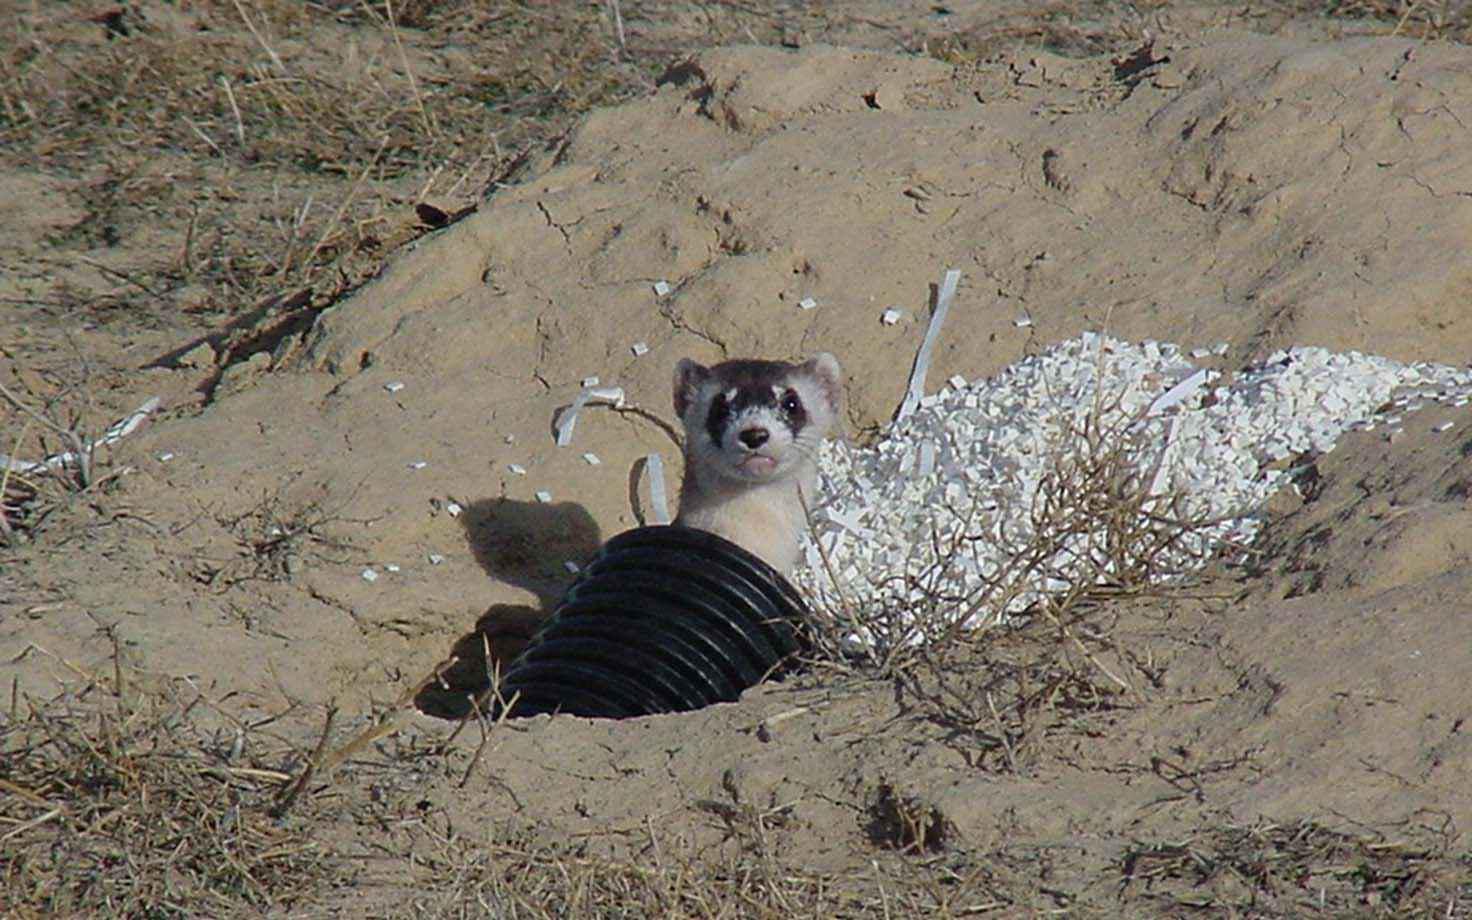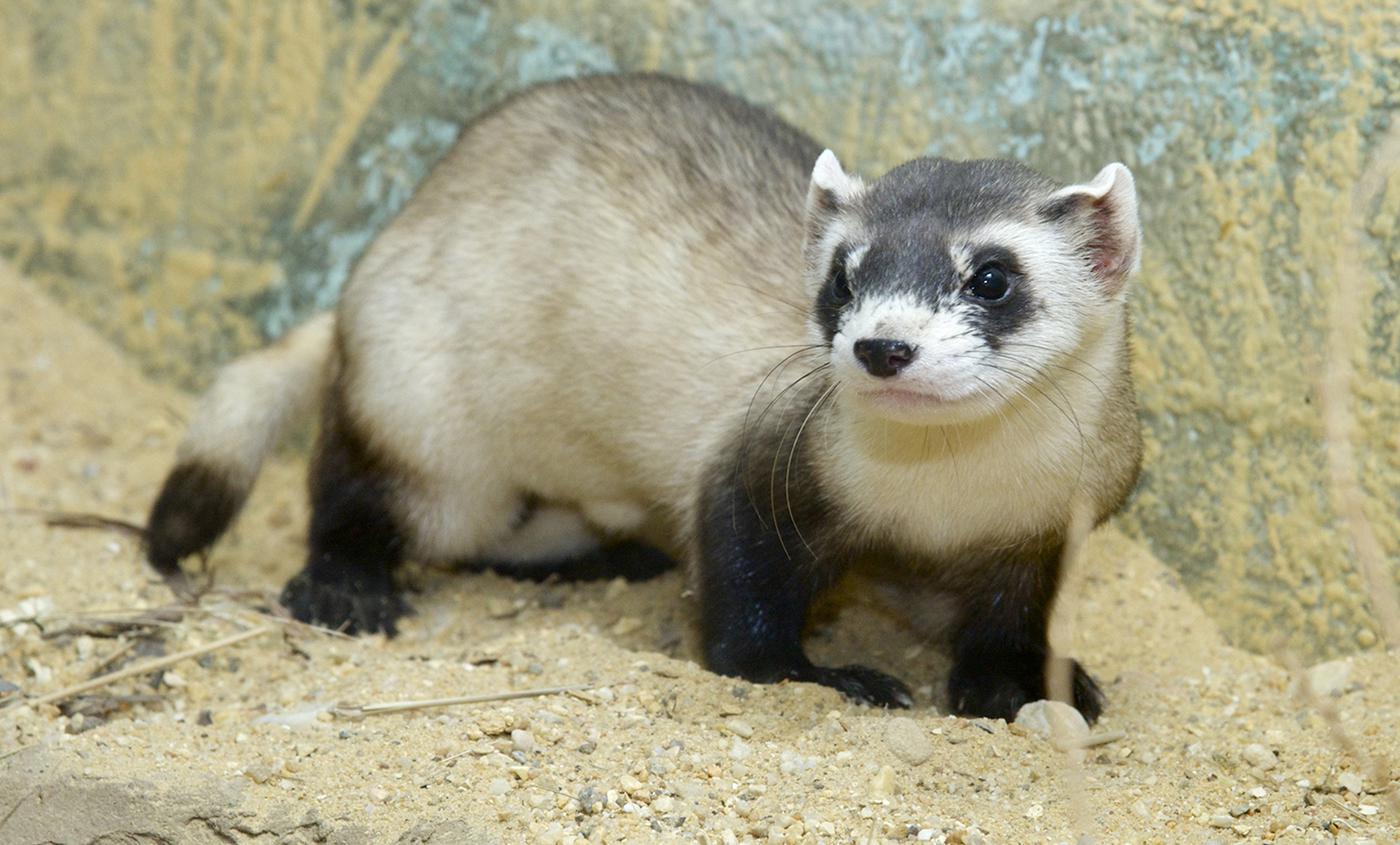The first image is the image on the left, the second image is the image on the right. Assess this claim about the two images: "There is at least two prairie dogs in the right image.". Correct or not? Answer yes or no. No. The first image is the image on the left, the second image is the image on the right. Examine the images to the left and right. Is the description "The left image shows one ferret emerging from a hole in the ground, and the right image contains multiple ferrets." accurate? Answer yes or no. No. 